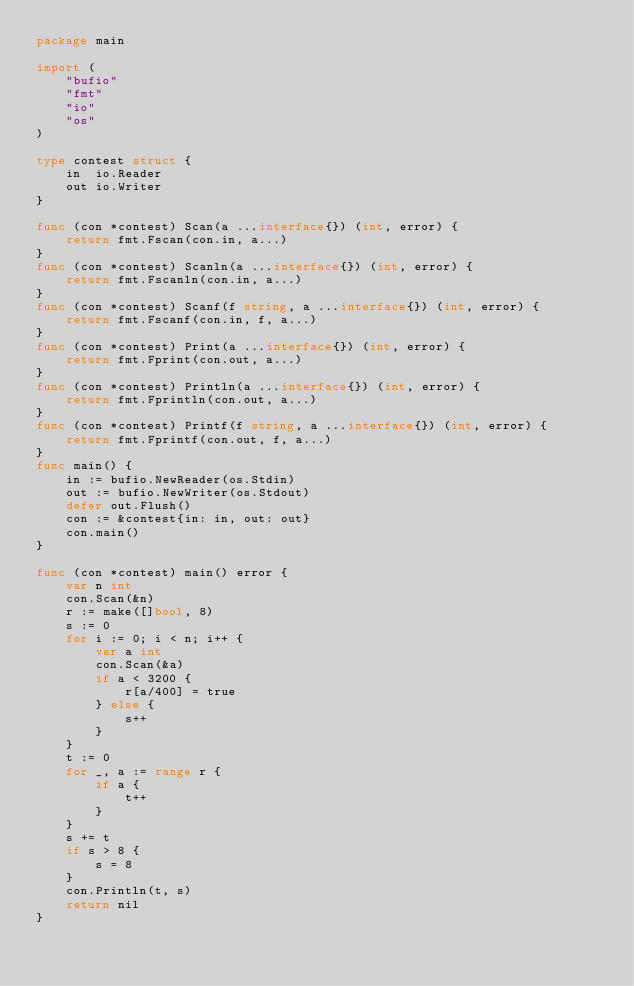Convert code to text. <code><loc_0><loc_0><loc_500><loc_500><_Go_>package main

import (
	"bufio"
	"fmt"
	"io"
	"os"
)

type contest struct {
	in  io.Reader
	out io.Writer
}

func (con *contest) Scan(a ...interface{}) (int, error) {
	return fmt.Fscan(con.in, a...)
}
func (con *contest) Scanln(a ...interface{}) (int, error) {
	return fmt.Fscanln(con.in, a...)
}
func (con *contest) Scanf(f string, a ...interface{}) (int, error) {
	return fmt.Fscanf(con.in, f, a...)
}
func (con *contest) Print(a ...interface{}) (int, error) {
	return fmt.Fprint(con.out, a...)
}
func (con *contest) Println(a ...interface{}) (int, error) {
	return fmt.Fprintln(con.out, a...)
}
func (con *contest) Printf(f string, a ...interface{}) (int, error) {
	return fmt.Fprintf(con.out, f, a...)
}
func main() {
	in := bufio.NewReader(os.Stdin)
	out := bufio.NewWriter(os.Stdout)
	defer out.Flush()
	con := &contest{in: in, out: out}
	con.main()
}

func (con *contest) main() error {
	var n int
	con.Scan(&n)
	r := make([]bool, 8)
	s := 0
	for i := 0; i < n; i++ {
		var a int
		con.Scan(&a)
		if a < 3200 {
			r[a/400] = true
		} else {
			s++
		}
	}
	t := 0
	for _, a := range r {
		if a {
			t++
		}
	}
	s += t
	if s > 8 {
		s = 8
	}
	con.Println(t, s)
	return nil
}
</code> 